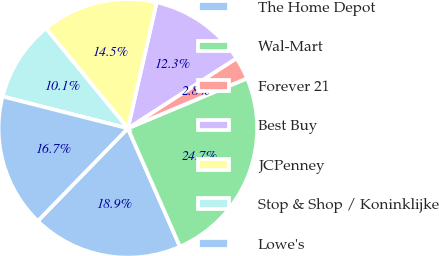<chart> <loc_0><loc_0><loc_500><loc_500><pie_chart><fcel>The Home Depot<fcel>Wal-Mart<fcel>Forever 21<fcel>Best Buy<fcel>JCPenney<fcel>Stop & Shop / Koninklijke<fcel>Lowe's<nl><fcel>18.88%<fcel>24.72%<fcel>2.8%<fcel>12.31%<fcel>14.5%<fcel>10.11%<fcel>16.69%<nl></chart> 